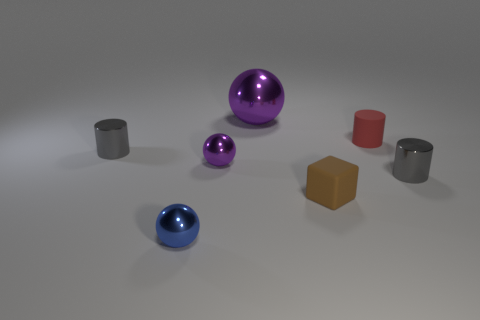Are there any other things that have the same shape as the small brown thing?
Give a very brief answer. No. What is the color of the small sphere on the right side of the blue metallic sphere?
Your answer should be very brief. Purple. How many metal things are cubes or balls?
Provide a short and direct response. 3. What material is the tiny gray cylinder that is to the right of the purple shiny ball behind the tiny matte cylinder?
Offer a very short reply. Metal. There is a ball that is the same color as the large thing; what is it made of?
Keep it short and to the point. Metal. The large ball has what color?
Give a very brief answer. Purple. There is a small object in front of the brown rubber object; are there any small blue balls behind it?
Your answer should be very brief. No. What is the block made of?
Provide a short and direct response. Rubber. Does the gray cylinder that is on the left side of the blue sphere have the same material as the small sphere behind the tiny cube?
Provide a succinct answer. Yes. Is there anything else that has the same color as the large metal object?
Give a very brief answer. Yes. 